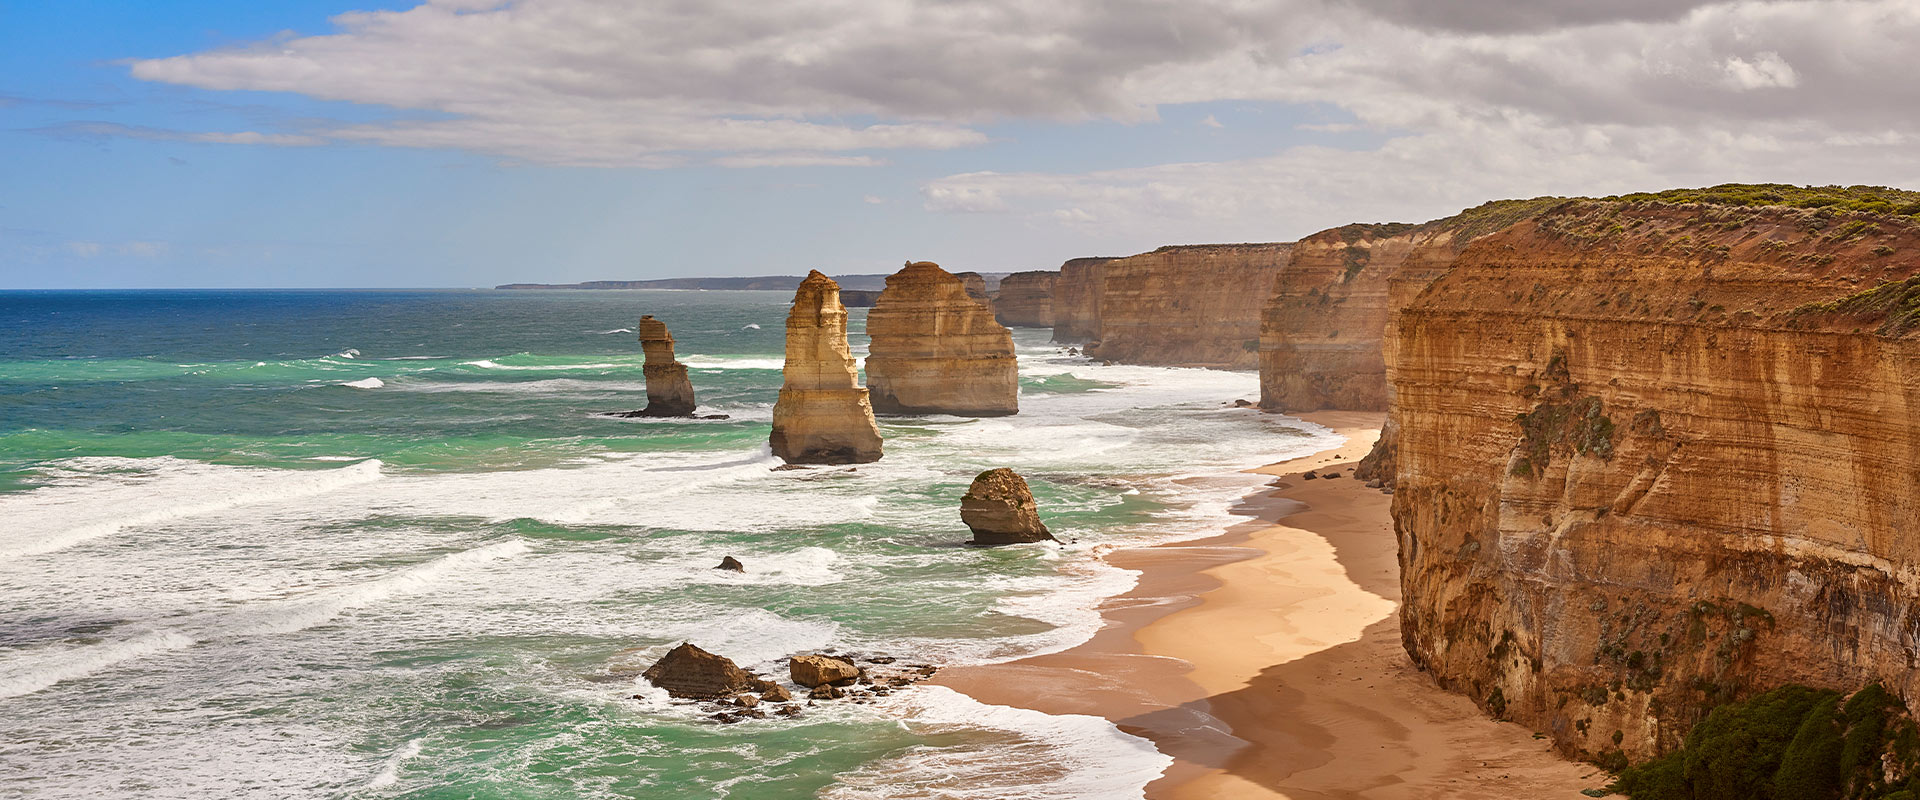Can you explain the importance of this location from an ecological or conservation perspective? The Twelve Apostles area is ecologically significant as it supports diverse marine and bird life, making it crucial for biodiversity conservation. The harsh rocky outposts provide nesting grounds for several seabird species. Additionally, the intertidal zones and submerged reefs around these stacks host complex marine ecosystems that include various species of fish and invertebrates, making conservation efforts essential to preserve these natural habitats from threats like climate change, pollution, and human interference. 